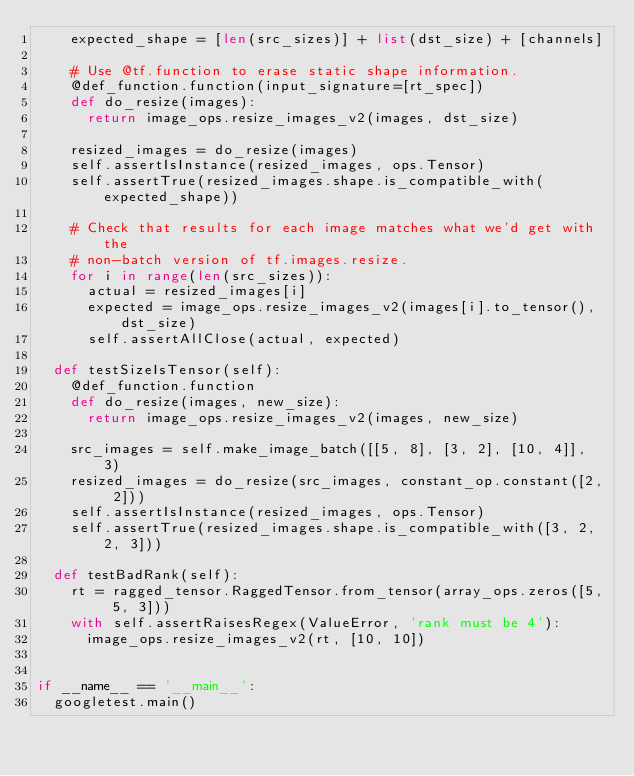<code> <loc_0><loc_0><loc_500><loc_500><_Python_>    expected_shape = [len(src_sizes)] + list(dst_size) + [channels]

    # Use @tf.function to erase static shape information.
    @def_function.function(input_signature=[rt_spec])
    def do_resize(images):
      return image_ops.resize_images_v2(images, dst_size)

    resized_images = do_resize(images)
    self.assertIsInstance(resized_images, ops.Tensor)
    self.assertTrue(resized_images.shape.is_compatible_with(expected_shape))

    # Check that results for each image matches what we'd get with the
    # non-batch version of tf.images.resize.
    for i in range(len(src_sizes)):
      actual = resized_images[i]
      expected = image_ops.resize_images_v2(images[i].to_tensor(), dst_size)
      self.assertAllClose(actual, expected)

  def testSizeIsTensor(self):
    @def_function.function
    def do_resize(images, new_size):
      return image_ops.resize_images_v2(images, new_size)

    src_images = self.make_image_batch([[5, 8], [3, 2], [10, 4]], 3)
    resized_images = do_resize(src_images, constant_op.constant([2, 2]))
    self.assertIsInstance(resized_images, ops.Tensor)
    self.assertTrue(resized_images.shape.is_compatible_with([3, 2, 2, 3]))

  def testBadRank(self):
    rt = ragged_tensor.RaggedTensor.from_tensor(array_ops.zeros([5, 5, 3]))
    with self.assertRaisesRegex(ValueError, 'rank must be 4'):
      image_ops.resize_images_v2(rt, [10, 10])


if __name__ == '__main__':
  googletest.main()
</code> 